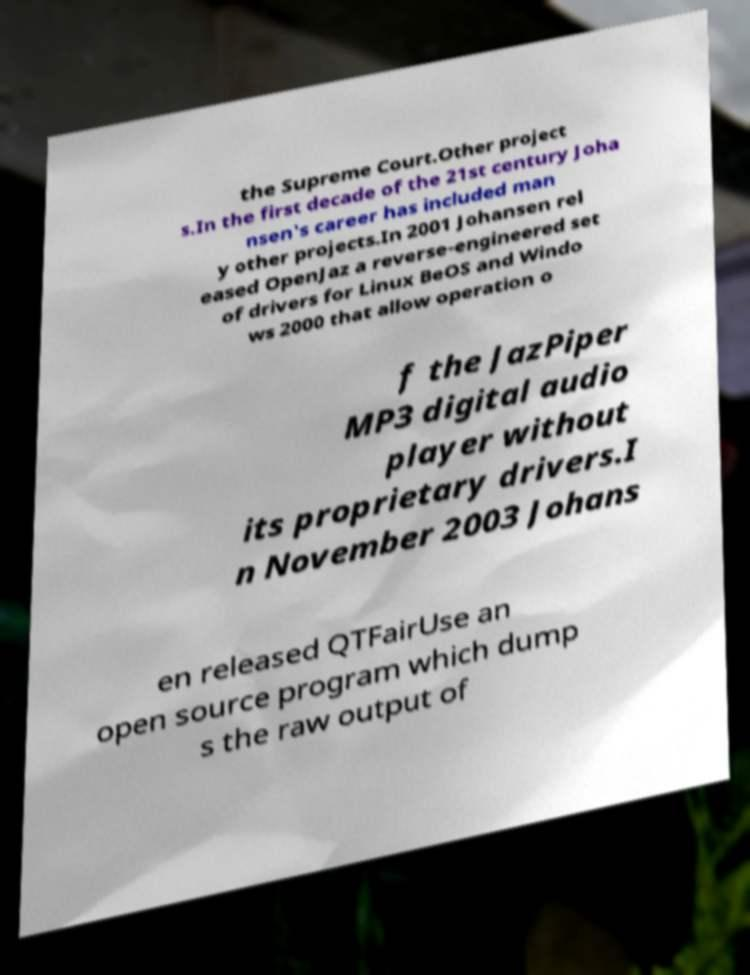I need the written content from this picture converted into text. Can you do that? the Supreme Court.Other project s.In the first decade of the 21st century Joha nsen's career has included man y other projects.In 2001 Johansen rel eased OpenJaz a reverse-engineered set of drivers for Linux BeOS and Windo ws 2000 that allow operation o f the JazPiper MP3 digital audio player without its proprietary drivers.I n November 2003 Johans en released QTFairUse an open source program which dump s the raw output of 